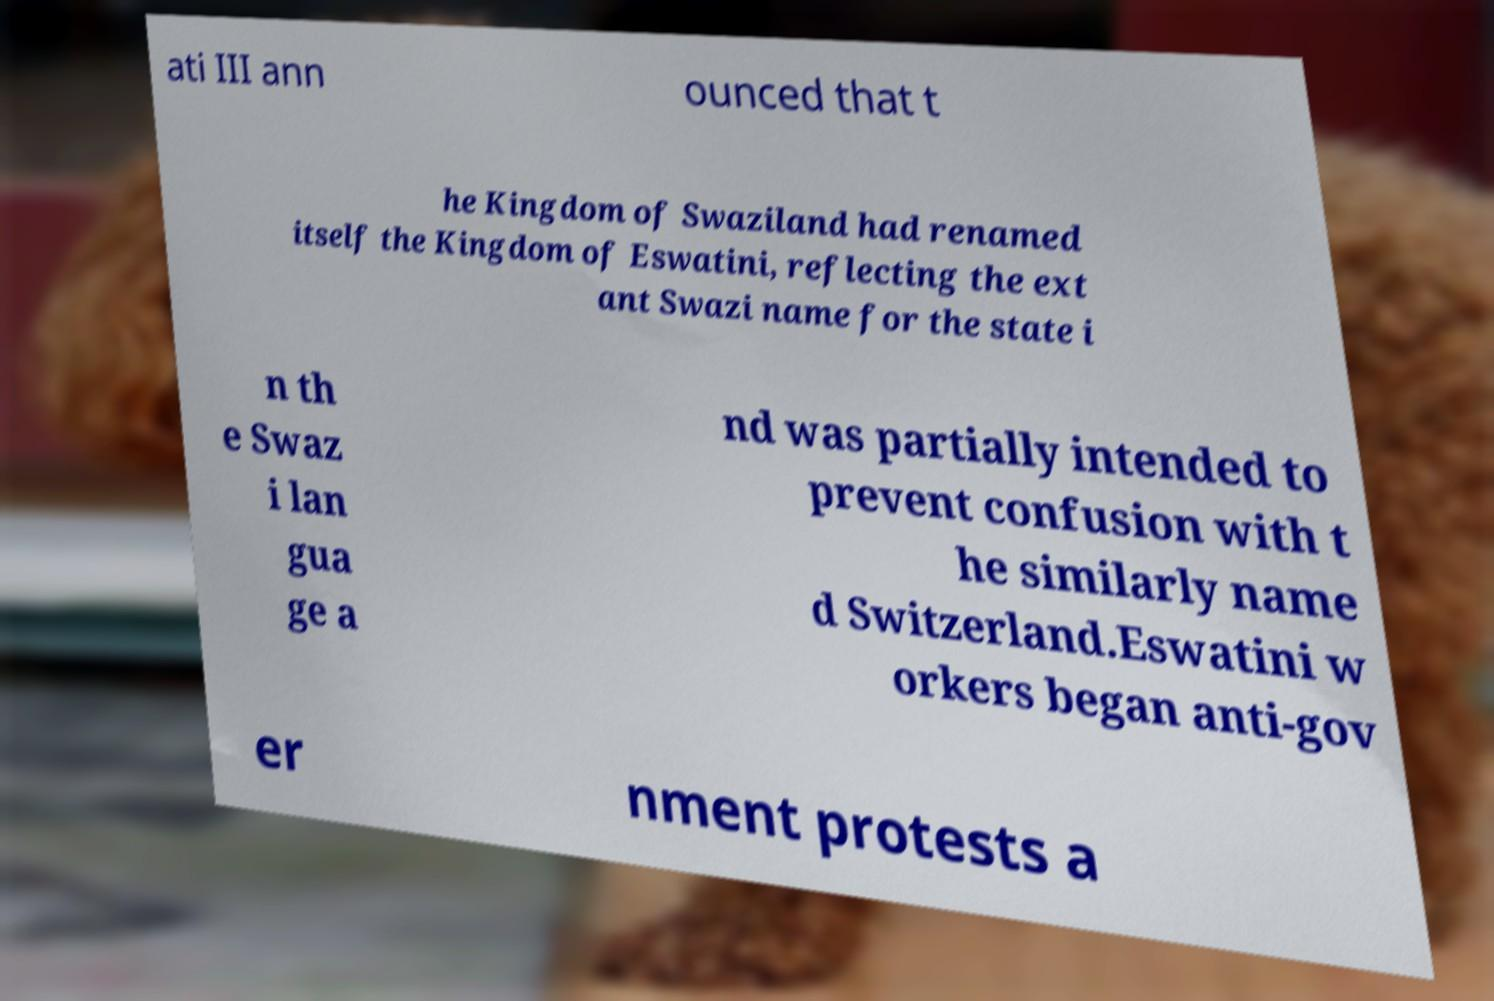Could you assist in decoding the text presented in this image and type it out clearly? ati III ann ounced that t he Kingdom of Swaziland had renamed itself the Kingdom of Eswatini, reflecting the ext ant Swazi name for the state i n th e Swaz i lan gua ge a nd was partially intended to prevent confusion with t he similarly name d Switzerland.Eswatini w orkers began anti-gov er nment protests a 